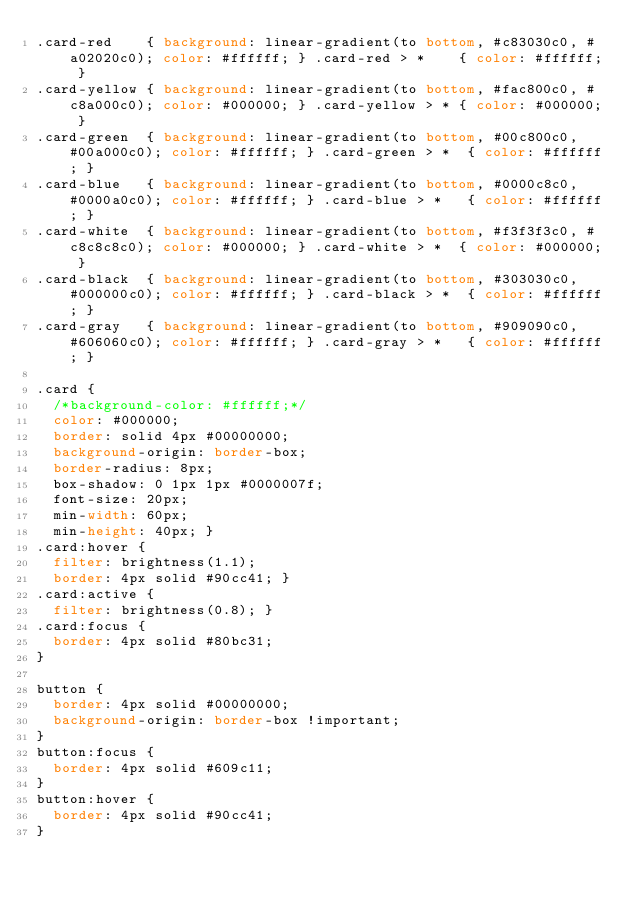<code> <loc_0><loc_0><loc_500><loc_500><_CSS_>.card-red    { background: linear-gradient(to bottom, #c83030c0, #a02020c0); color: #ffffff; } .card-red > *    { color: #ffffff; }
.card-yellow { background: linear-gradient(to bottom, #fac800c0, #c8a000c0); color: #000000; } .card-yellow > * { color: #000000; }
.card-green  { background: linear-gradient(to bottom, #00c800c0, #00a000c0); color: #ffffff; } .card-green > *  { color: #ffffff; }
.card-blue   { background: linear-gradient(to bottom, #0000c8c0, #0000a0c0); color: #ffffff; } .card-blue > *   { color: #ffffff; }
.card-white  { background: linear-gradient(to bottom, #f3f3f3c0, #c8c8c8c0); color: #000000; } .card-white > *  { color: #000000; }
.card-black  { background: linear-gradient(to bottom, #303030c0, #000000c0); color: #ffffff; } .card-black > *  { color: #ffffff; }
.card-gray   { background: linear-gradient(to bottom, #909090c0, #606060c0); color: #ffffff; } .card-gray > *   { color: #ffffff; }

.card {
  /*background-color: #ffffff;*/
  color: #000000;
  border: solid 4px #00000000;
  background-origin: border-box;
  border-radius: 8px;
  box-shadow: 0 1px 1px #0000007f;
  font-size: 20px;
  min-width: 60px;
  min-height: 40px; }
.card:hover {
  filter: brightness(1.1);
  border: 4px solid #90cc41; }
.card:active {
  filter: brightness(0.8); }
.card:focus {
  border: 4px solid #80bc31;
}

button {
  border: 4px solid #00000000;
  background-origin: border-box !important;
}
button:focus {
  border: 4px solid #609c11;
}
button:hover {
  border: 4px solid #90cc41;
}
</code> 